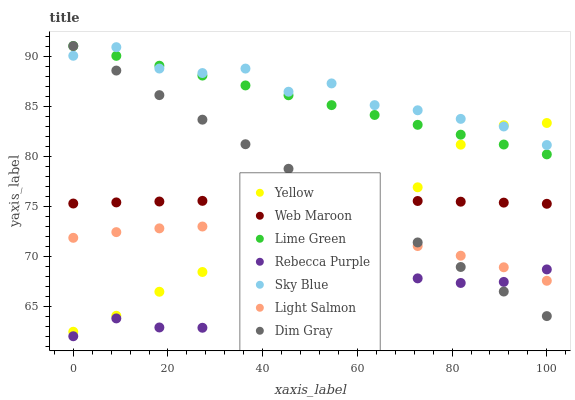Does Rebecca Purple have the minimum area under the curve?
Answer yes or no. Yes. Does Sky Blue have the maximum area under the curve?
Answer yes or no. Yes. Does Dim Gray have the minimum area under the curve?
Answer yes or no. No. Does Dim Gray have the maximum area under the curve?
Answer yes or no. No. Is Dim Gray the smoothest?
Answer yes or no. Yes. Is Yellow the roughest?
Answer yes or no. Yes. Is Web Maroon the smoothest?
Answer yes or no. No. Is Web Maroon the roughest?
Answer yes or no. No. Does Rebecca Purple have the lowest value?
Answer yes or no. Yes. Does Dim Gray have the lowest value?
Answer yes or no. No. Does Lime Green have the highest value?
Answer yes or no. Yes. Does Web Maroon have the highest value?
Answer yes or no. No. Is Light Salmon less than Sky Blue?
Answer yes or no. Yes. Is Lime Green greater than Light Salmon?
Answer yes or no. Yes. Does Rebecca Purple intersect Light Salmon?
Answer yes or no. Yes. Is Rebecca Purple less than Light Salmon?
Answer yes or no. No. Is Rebecca Purple greater than Light Salmon?
Answer yes or no. No. Does Light Salmon intersect Sky Blue?
Answer yes or no. No. 